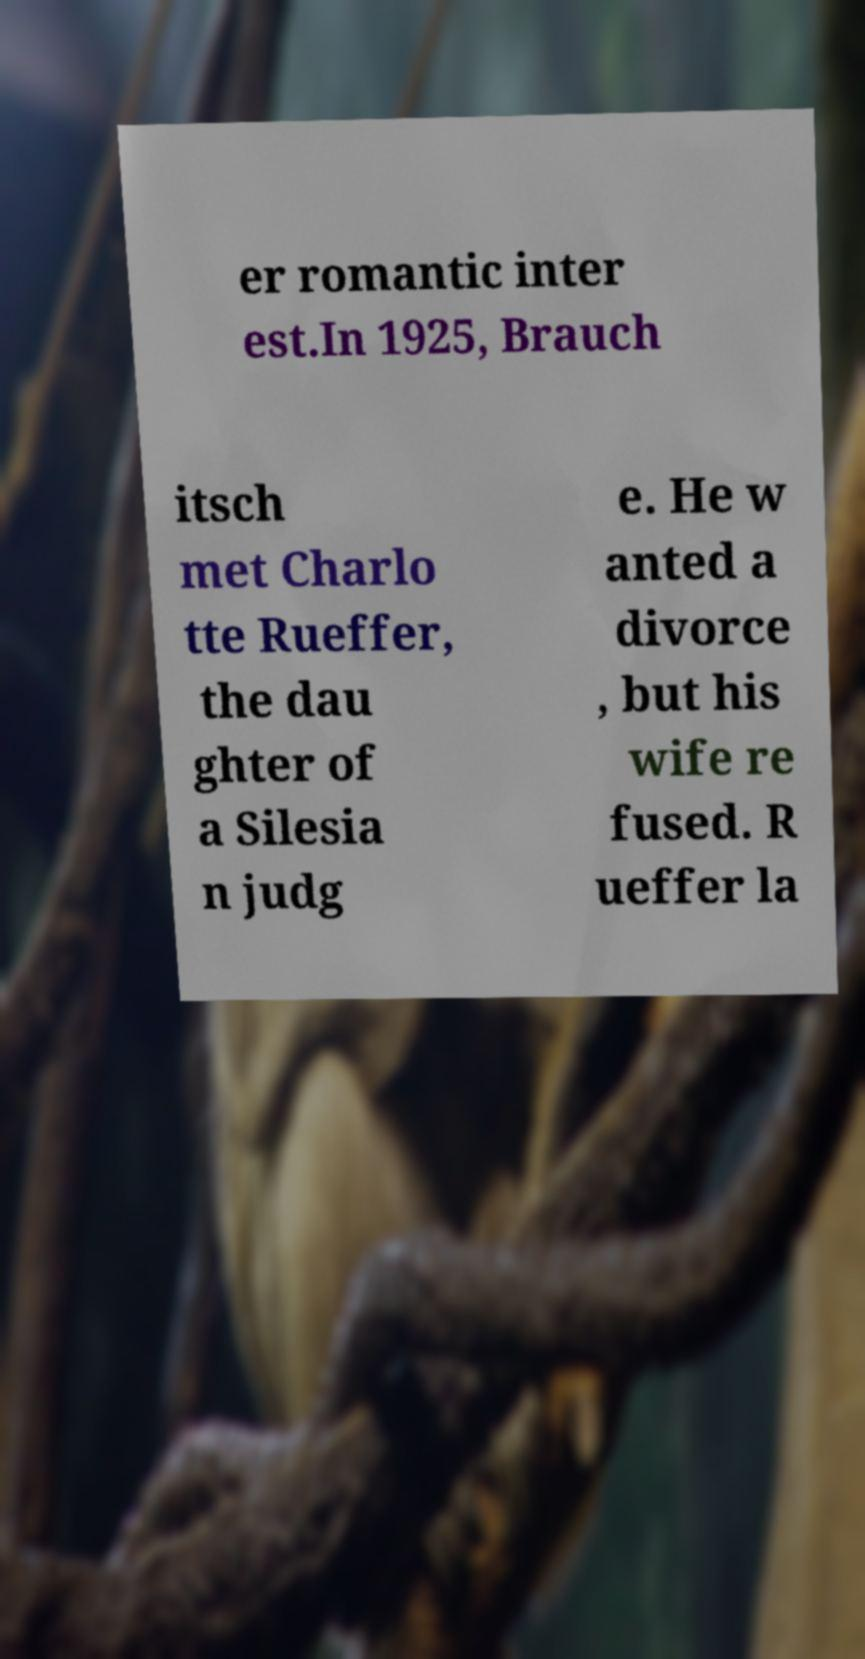Could you extract and type out the text from this image? er romantic inter est.In 1925, Brauch itsch met Charlo tte Rueffer, the dau ghter of a Silesia n judg e. He w anted a divorce , but his wife re fused. R ueffer la 